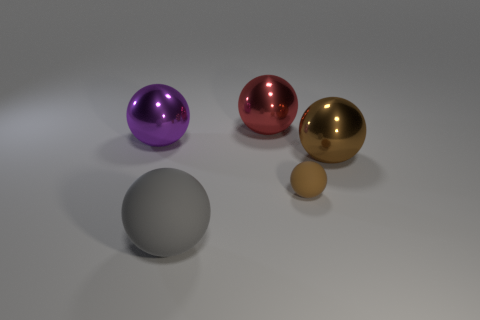Subtract all gray balls. How many balls are left? 4 Subtract all large brown metal spheres. How many spheres are left? 4 Subtract all cyan balls. Subtract all cyan blocks. How many balls are left? 5 Add 5 large spheres. How many objects exist? 10 Subtract all tiny rubber blocks. Subtract all big spheres. How many objects are left? 1 Add 1 small brown balls. How many small brown balls are left? 2 Add 2 matte balls. How many matte balls exist? 4 Subtract 0 brown cylinders. How many objects are left? 5 